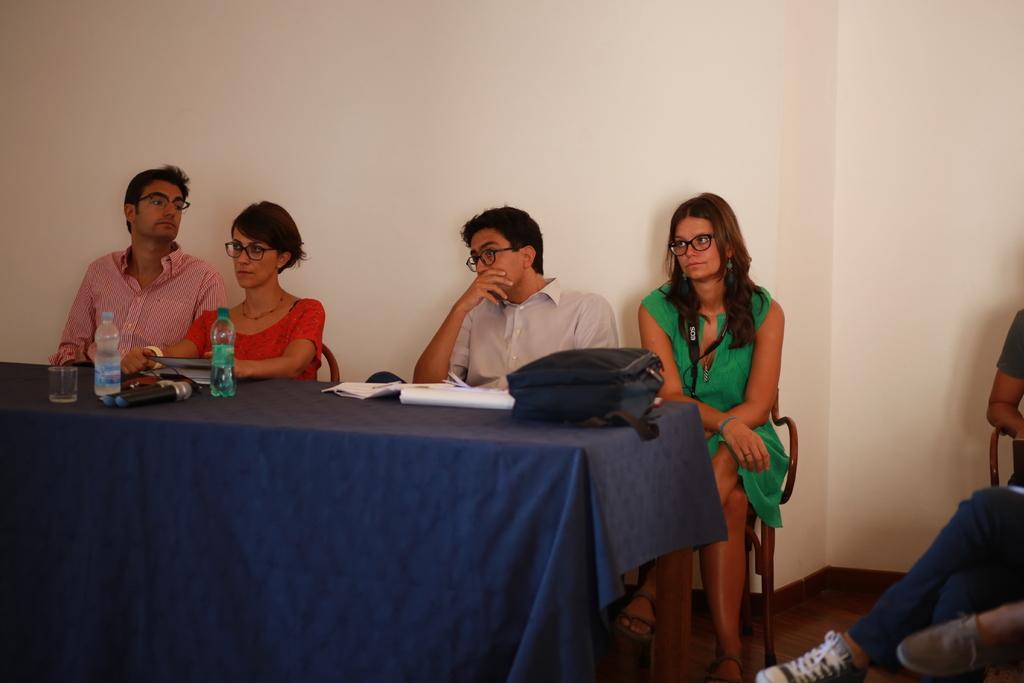How would you summarize this image in a sentence or two? In the image there are two men and two women sat on chair in front of table. The table has bag,cloth,water bottle on it and it is blue in color. Over the left side there is a guys legs are visible. 